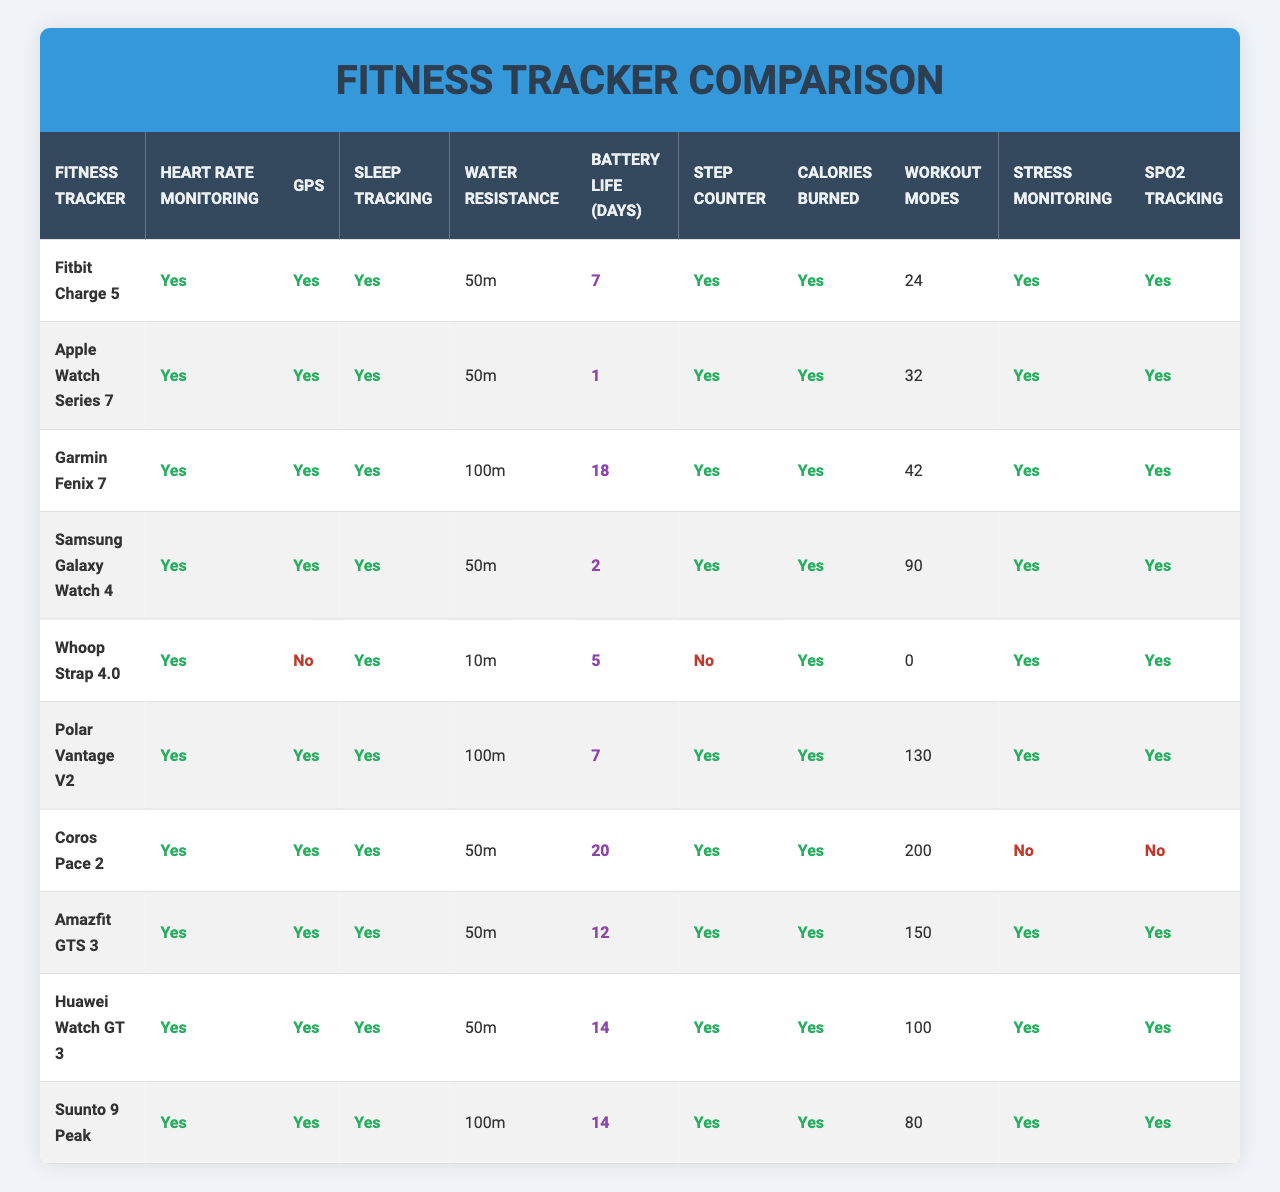What is the battery life of the Fitbit Charge 5? The battery life of the Fitbit Charge 5 is listed in the table under "Battery Life (days)," which shows a value of 7 days.
Answer: 7 days How many fitness trackers have GPS functionality? By looking at the "GPS" column, we see that 8 out of 10 fitness trackers have "Yes" listed under this feature.
Answer: 8 trackers Which fitness tracker has the longest battery life? To find the one with the longest battery life, we compare the values in the "Battery Life (days)" column. The Garmin Fenix 7 has the highest value of 18 days.
Answer: Garmin Fenix 7 Which tracker does not provide SpO2 tracking? Looking at the "SpO2 Tracking" column, the Coros Pace 2 and Whoop Strap 4.0 are marked as "No," indicating they do not provide this feature.
Answer: Coros Pace 2 and Whoop Strap 4.0 What is the average battery life of all fitness trackers listed? The total battery life is calculated by summing all the values: (7 + 1 + 18 + 2 + 5 + 7 + 20 + 12 + 14 + 14) = 100 days. There are 10 trackers, so the average is 100/10 = 10 days.
Answer: 10 days Which tracker offers the most workout modes? In the "Workout Modes" column, the Polar Vantage V2 shows a value of 130, which is the highest.
Answer: Polar Vantage V2 Is the Samsung Galaxy Watch 4 water-resistant? Checking the "Water Resistance" column, the Samsung Galaxy Watch 4 has "Yes" indicated, confirming it is water-resistant.
Answer: Yes Among the fitness trackers, which has the least number of workout modes and what is that number? The Whoop Strap 4.0 shows "0" in the "Workout Modes" column, making it the tracker with the least workout modes.
Answer: 0 workout modes How many fitness trackers are water-resistant up to 100 meters? From the "Water Resistance" column, we see that both the Garmin Fenix 7 and Polar Vantage V2 have a water resistance of 100 meters, resulting in a count of 2 trackers.
Answer: 2 trackers Which fitness tracker has heart rate monitoring but no GPS? The Whoop Strap 4.0 has "Yes" for heart rate monitoring and "No" for GPS as per their respective columns.
Answer: Whoop Strap 4.0 